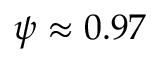Convert formula to latex. <formula><loc_0><loc_0><loc_500><loc_500>\psi \approx 0 . 9 7</formula> 